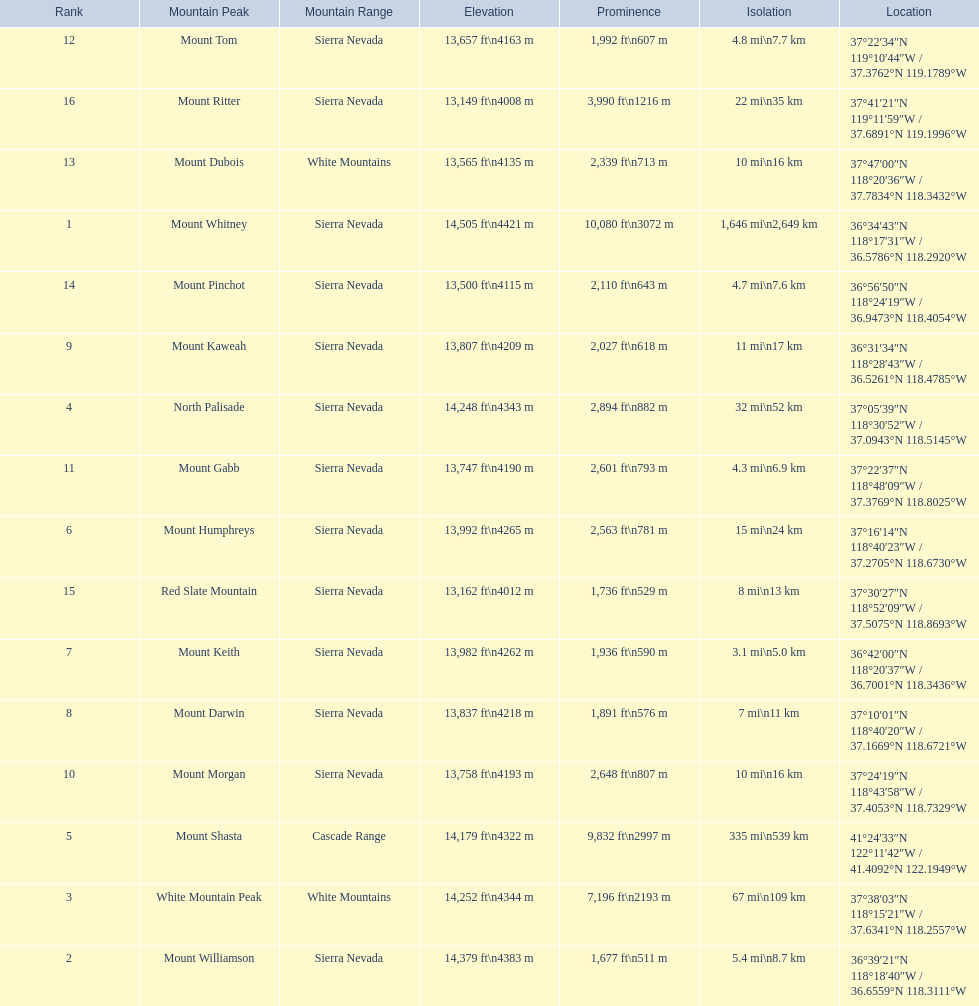What are all of the mountain peaks? Mount Whitney, Mount Williamson, White Mountain Peak, North Palisade, Mount Shasta, Mount Humphreys, Mount Keith, Mount Darwin, Mount Kaweah, Mount Morgan, Mount Gabb, Mount Tom, Mount Dubois, Mount Pinchot, Red Slate Mountain, Mount Ritter. In what ranges are they located? Sierra Nevada, Sierra Nevada, White Mountains, Sierra Nevada, Cascade Range, Sierra Nevada, Sierra Nevada, Sierra Nevada, Sierra Nevada, Sierra Nevada, Sierra Nevada, Sierra Nevada, White Mountains, Sierra Nevada, Sierra Nevada, Sierra Nevada. And which mountain peak is in the cascade range? Mount Shasta. 